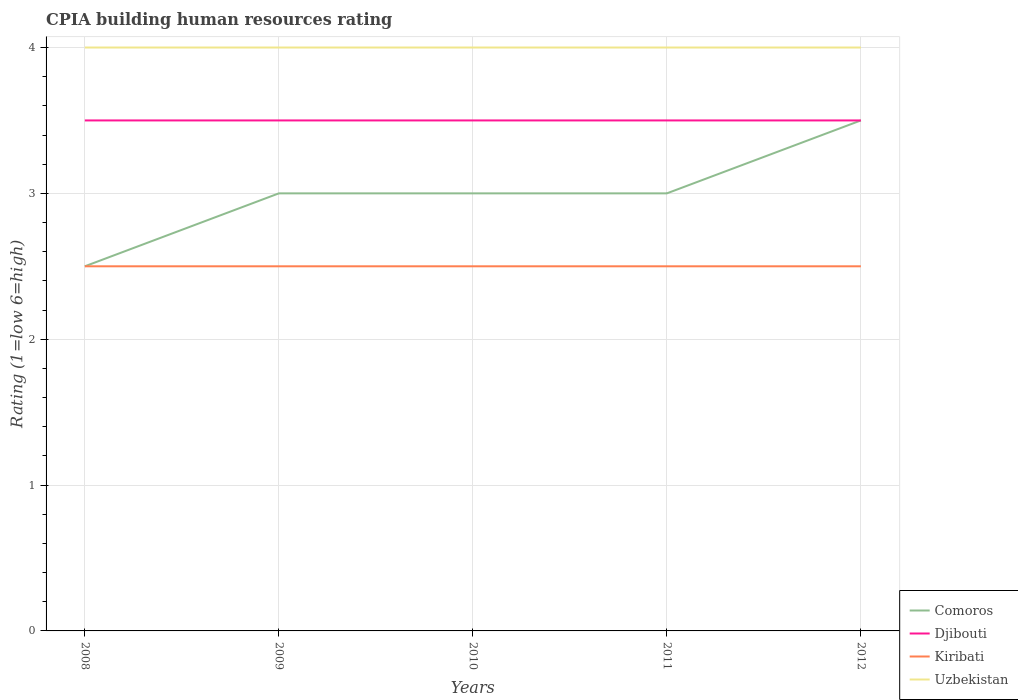Is the number of lines equal to the number of legend labels?
Offer a terse response. Yes. Across all years, what is the maximum CPIA rating in Uzbekistan?
Offer a very short reply. 4. How many lines are there?
Ensure brevity in your answer.  4. How many years are there in the graph?
Provide a short and direct response. 5. Are the values on the major ticks of Y-axis written in scientific E-notation?
Ensure brevity in your answer.  No. Does the graph contain grids?
Your answer should be very brief. Yes. Where does the legend appear in the graph?
Give a very brief answer. Bottom right. How many legend labels are there?
Provide a short and direct response. 4. How are the legend labels stacked?
Keep it short and to the point. Vertical. What is the title of the graph?
Provide a short and direct response. CPIA building human resources rating. Does "San Marino" appear as one of the legend labels in the graph?
Give a very brief answer. No. What is the Rating (1=low 6=high) in Djibouti in 2008?
Provide a short and direct response. 3.5. What is the Rating (1=low 6=high) of Kiribati in 2008?
Ensure brevity in your answer.  2.5. What is the Rating (1=low 6=high) in Uzbekistan in 2008?
Your answer should be very brief. 4. What is the Rating (1=low 6=high) of Djibouti in 2009?
Keep it short and to the point. 3.5. What is the Rating (1=low 6=high) in Kiribati in 2009?
Provide a short and direct response. 2.5. What is the Rating (1=low 6=high) of Comoros in 2010?
Provide a succinct answer. 3. What is the Rating (1=low 6=high) in Djibouti in 2010?
Your answer should be compact. 3.5. What is the Rating (1=low 6=high) of Kiribati in 2010?
Offer a terse response. 2.5. What is the Rating (1=low 6=high) of Uzbekistan in 2010?
Provide a succinct answer. 4. What is the Rating (1=low 6=high) in Comoros in 2011?
Offer a terse response. 3. What is the Rating (1=low 6=high) in Djibouti in 2011?
Provide a short and direct response. 3.5. What is the Rating (1=low 6=high) in Comoros in 2012?
Offer a very short reply. 3.5. What is the Rating (1=low 6=high) in Djibouti in 2012?
Your response must be concise. 3.5. What is the Rating (1=low 6=high) of Uzbekistan in 2012?
Ensure brevity in your answer.  4. Across all years, what is the maximum Rating (1=low 6=high) in Djibouti?
Offer a terse response. 3.5. Across all years, what is the maximum Rating (1=low 6=high) in Kiribati?
Offer a terse response. 2.5. Across all years, what is the minimum Rating (1=low 6=high) in Comoros?
Keep it short and to the point. 2.5. Across all years, what is the minimum Rating (1=low 6=high) in Djibouti?
Your answer should be compact. 3.5. Across all years, what is the minimum Rating (1=low 6=high) in Kiribati?
Make the answer very short. 2.5. Across all years, what is the minimum Rating (1=low 6=high) in Uzbekistan?
Keep it short and to the point. 4. What is the total Rating (1=low 6=high) of Comoros in the graph?
Provide a succinct answer. 15. What is the total Rating (1=low 6=high) in Uzbekistan in the graph?
Your answer should be compact. 20. What is the difference between the Rating (1=low 6=high) of Djibouti in 2008 and that in 2010?
Ensure brevity in your answer.  0. What is the difference between the Rating (1=low 6=high) in Kiribati in 2008 and that in 2010?
Offer a terse response. 0. What is the difference between the Rating (1=low 6=high) of Uzbekistan in 2008 and that in 2010?
Make the answer very short. 0. What is the difference between the Rating (1=low 6=high) in Comoros in 2008 and that in 2011?
Offer a terse response. -0.5. What is the difference between the Rating (1=low 6=high) of Djibouti in 2008 and that in 2011?
Offer a terse response. 0. What is the difference between the Rating (1=low 6=high) in Uzbekistan in 2008 and that in 2011?
Provide a short and direct response. 0. What is the difference between the Rating (1=low 6=high) in Comoros in 2008 and that in 2012?
Your answer should be very brief. -1. What is the difference between the Rating (1=low 6=high) in Kiribati in 2008 and that in 2012?
Your answer should be compact. 0. What is the difference between the Rating (1=low 6=high) of Uzbekistan in 2009 and that in 2010?
Offer a very short reply. 0. What is the difference between the Rating (1=low 6=high) of Djibouti in 2009 and that in 2012?
Offer a terse response. 0. What is the difference between the Rating (1=low 6=high) in Kiribati in 2009 and that in 2012?
Your answer should be very brief. 0. What is the difference between the Rating (1=low 6=high) of Comoros in 2010 and that in 2012?
Offer a terse response. -0.5. What is the difference between the Rating (1=low 6=high) of Kiribati in 2010 and that in 2012?
Keep it short and to the point. 0. What is the difference between the Rating (1=low 6=high) of Uzbekistan in 2010 and that in 2012?
Your response must be concise. 0. What is the difference between the Rating (1=low 6=high) of Kiribati in 2011 and that in 2012?
Offer a terse response. 0. What is the difference between the Rating (1=low 6=high) in Comoros in 2008 and the Rating (1=low 6=high) in Djibouti in 2009?
Give a very brief answer. -1. What is the difference between the Rating (1=low 6=high) in Djibouti in 2008 and the Rating (1=low 6=high) in Kiribati in 2009?
Make the answer very short. 1. What is the difference between the Rating (1=low 6=high) in Kiribati in 2008 and the Rating (1=low 6=high) in Uzbekistan in 2009?
Your response must be concise. -1.5. What is the difference between the Rating (1=low 6=high) of Comoros in 2008 and the Rating (1=low 6=high) of Kiribati in 2010?
Offer a very short reply. 0. What is the difference between the Rating (1=low 6=high) in Comoros in 2008 and the Rating (1=low 6=high) in Uzbekistan in 2010?
Provide a succinct answer. -1.5. What is the difference between the Rating (1=low 6=high) in Djibouti in 2008 and the Rating (1=low 6=high) in Uzbekistan in 2010?
Offer a terse response. -0.5. What is the difference between the Rating (1=low 6=high) in Kiribati in 2008 and the Rating (1=low 6=high) in Uzbekistan in 2010?
Give a very brief answer. -1.5. What is the difference between the Rating (1=low 6=high) in Djibouti in 2008 and the Rating (1=low 6=high) in Uzbekistan in 2011?
Offer a terse response. -0.5. What is the difference between the Rating (1=low 6=high) in Comoros in 2008 and the Rating (1=low 6=high) in Kiribati in 2012?
Your response must be concise. 0. What is the difference between the Rating (1=low 6=high) of Djibouti in 2008 and the Rating (1=low 6=high) of Kiribati in 2012?
Offer a terse response. 1. What is the difference between the Rating (1=low 6=high) of Kiribati in 2008 and the Rating (1=low 6=high) of Uzbekistan in 2012?
Make the answer very short. -1.5. What is the difference between the Rating (1=low 6=high) in Comoros in 2009 and the Rating (1=low 6=high) in Kiribati in 2010?
Give a very brief answer. 0.5. What is the difference between the Rating (1=low 6=high) of Djibouti in 2009 and the Rating (1=low 6=high) of Kiribati in 2011?
Offer a terse response. 1. What is the difference between the Rating (1=low 6=high) in Djibouti in 2009 and the Rating (1=low 6=high) in Uzbekistan in 2011?
Provide a short and direct response. -0.5. What is the difference between the Rating (1=low 6=high) of Comoros in 2009 and the Rating (1=low 6=high) of Djibouti in 2012?
Your response must be concise. -0.5. What is the difference between the Rating (1=low 6=high) of Comoros in 2009 and the Rating (1=low 6=high) of Kiribati in 2012?
Provide a succinct answer. 0.5. What is the difference between the Rating (1=low 6=high) in Djibouti in 2009 and the Rating (1=low 6=high) in Uzbekistan in 2012?
Give a very brief answer. -0.5. What is the difference between the Rating (1=low 6=high) in Kiribati in 2009 and the Rating (1=low 6=high) in Uzbekistan in 2012?
Make the answer very short. -1.5. What is the difference between the Rating (1=low 6=high) of Djibouti in 2010 and the Rating (1=low 6=high) of Uzbekistan in 2011?
Provide a short and direct response. -0.5. What is the difference between the Rating (1=low 6=high) in Djibouti in 2010 and the Rating (1=low 6=high) in Kiribati in 2012?
Provide a short and direct response. 1. What is the difference between the Rating (1=low 6=high) in Djibouti in 2010 and the Rating (1=low 6=high) in Uzbekistan in 2012?
Give a very brief answer. -0.5. What is the difference between the Rating (1=low 6=high) in Kiribati in 2010 and the Rating (1=low 6=high) in Uzbekistan in 2012?
Offer a terse response. -1.5. What is the difference between the Rating (1=low 6=high) of Djibouti in 2011 and the Rating (1=low 6=high) of Kiribati in 2012?
Offer a terse response. 1. What is the average Rating (1=low 6=high) in Comoros per year?
Make the answer very short. 3. What is the average Rating (1=low 6=high) of Djibouti per year?
Provide a short and direct response. 3.5. What is the average Rating (1=low 6=high) in Kiribati per year?
Offer a very short reply. 2.5. What is the average Rating (1=low 6=high) of Uzbekistan per year?
Make the answer very short. 4. In the year 2008, what is the difference between the Rating (1=low 6=high) in Djibouti and Rating (1=low 6=high) in Uzbekistan?
Give a very brief answer. -0.5. In the year 2009, what is the difference between the Rating (1=low 6=high) of Comoros and Rating (1=low 6=high) of Djibouti?
Ensure brevity in your answer.  -0.5. In the year 2009, what is the difference between the Rating (1=low 6=high) in Comoros and Rating (1=low 6=high) in Kiribati?
Keep it short and to the point. 0.5. In the year 2009, what is the difference between the Rating (1=low 6=high) in Djibouti and Rating (1=low 6=high) in Kiribati?
Provide a short and direct response. 1. In the year 2009, what is the difference between the Rating (1=low 6=high) of Djibouti and Rating (1=low 6=high) of Uzbekistan?
Your answer should be very brief. -0.5. In the year 2009, what is the difference between the Rating (1=low 6=high) in Kiribati and Rating (1=low 6=high) in Uzbekistan?
Make the answer very short. -1.5. In the year 2010, what is the difference between the Rating (1=low 6=high) of Comoros and Rating (1=low 6=high) of Djibouti?
Provide a short and direct response. -0.5. In the year 2010, what is the difference between the Rating (1=low 6=high) in Comoros and Rating (1=low 6=high) in Kiribati?
Offer a terse response. 0.5. In the year 2010, what is the difference between the Rating (1=low 6=high) in Comoros and Rating (1=low 6=high) in Uzbekistan?
Provide a succinct answer. -1. In the year 2010, what is the difference between the Rating (1=low 6=high) in Kiribati and Rating (1=low 6=high) in Uzbekistan?
Give a very brief answer. -1.5. In the year 2011, what is the difference between the Rating (1=low 6=high) of Comoros and Rating (1=low 6=high) of Kiribati?
Give a very brief answer. 0.5. In the year 2011, what is the difference between the Rating (1=low 6=high) of Djibouti and Rating (1=low 6=high) of Uzbekistan?
Provide a succinct answer. -0.5. In the year 2011, what is the difference between the Rating (1=low 6=high) in Kiribati and Rating (1=low 6=high) in Uzbekistan?
Your response must be concise. -1.5. What is the ratio of the Rating (1=low 6=high) in Comoros in 2008 to that in 2009?
Offer a very short reply. 0.83. What is the ratio of the Rating (1=low 6=high) in Djibouti in 2008 to that in 2009?
Offer a terse response. 1. What is the ratio of the Rating (1=low 6=high) of Uzbekistan in 2008 to that in 2009?
Give a very brief answer. 1. What is the ratio of the Rating (1=low 6=high) of Comoros in 2008 to that in 2010?
Your response must be concise. 0.83. What is the ratio of the Rating (1=low 6=high) in Djibouti in 2008 to that in 2010?
Give a very brief answer. 1. What is the ratio of the Rating (1=low 6=high) in Djibouti in 2008 to that in 2011?
Give a very brief answer. 1. What is the ratio of the Rating (1=low 6=high) of Kiribati in 2009 to that in 2010?
Offer a very short reply. 1. What is the ratio of the Rating (1=low 6=high) of Uzbekistan in 2009 to that in 2010?
Provide a short and direct response. 1. What is the ratio of the Rating (1=low 6=high) of Djibouti in 2009 to that in 2011?
Provide a short and direct response. 1. What is the ratio of the Rating (1=low 6=high) of Kiribati in 2009 to that in 2011?
Give a very brief answer. 1. What is the ratio of the Rating (1=low 6=high) of Uzbekistan in 2009 to that in 2011?
Keep it short and to the point. 1. What is the ratio of the Rating (1=low 6=high) of Djibouti in 2009 to that in 2012?
Provide a short and direct response. 1. What is the ratio of the Rating (1=low 6=high) of Uzbekistan in 2009 to that in 2012?
Give a very brief answer. 1. What is the ratio of the Rating (1=low 6=high) in Djibouti in 2010 to that in 2011?
Make the answer very short. 1. What is the ratio of the Rating (1=low 6=high) of Uzbekistan in 2010 to that in 2011?
Your answer should be very brief. 1. What is the ratio of the Rating (1=low 6=high) of Comoros in 2011 to that in 2012?
Offer a terse response. 0.86. What is the ratio of the Rating (1=low 6=high) of Djibouti in 2011 to that in 2012?
Provide a short and direct response. 1. What is the ratio of the Rating (1=low 6=high) of Kiribati in 2011 to that in 2012?
Offer a very short reply. 1. What is the ratio of the Rating (1=low 6=high) in Uzbekistan in 2011 to that in 2012?
Offer a very short reply. 1. What is the difference between the highest and the second highest Rating (1=low 6=high) of Comoros?
Offer a terse response. 0.5. What is the difference between the highest and the lowest Rating (1=low 6=high) of Djibouti?
Offer a terse response. 0. What is the difference between the highest and the lowest Rating (1=low 6=high) of Kiribati?
Keep it short and to the point. 0. 